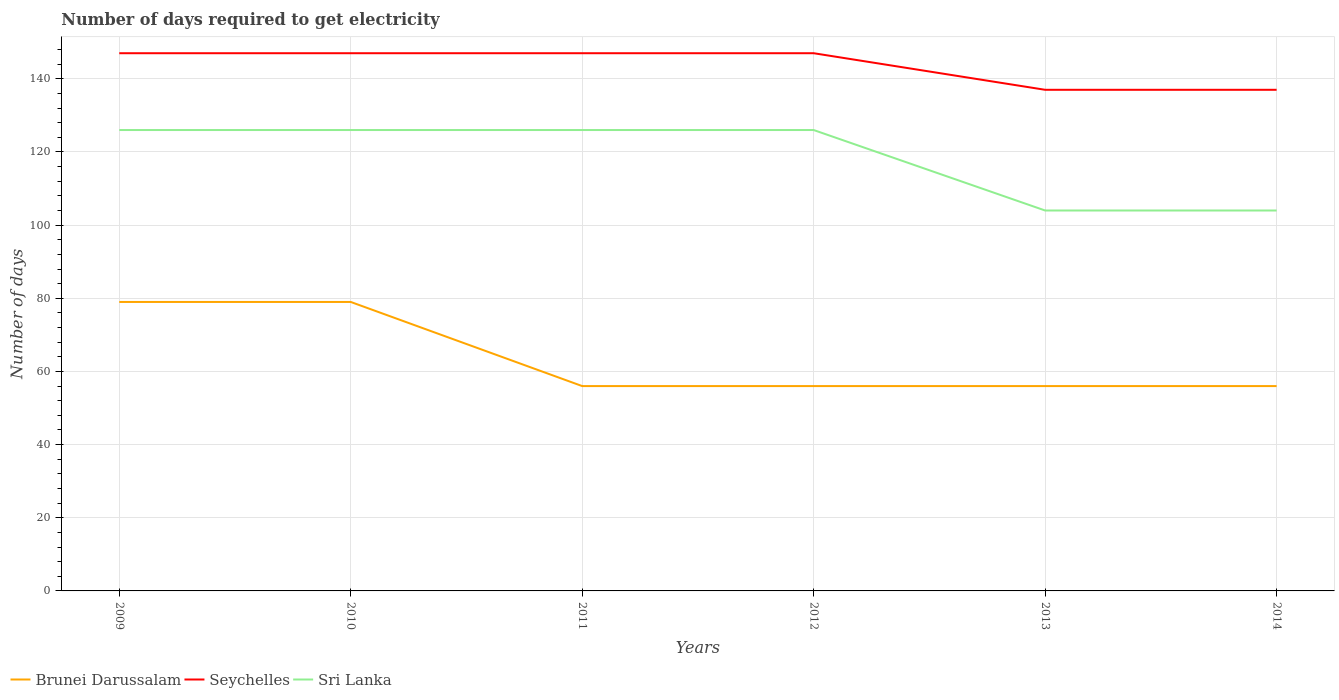Does the line corresponding to Sri Lanka intersect with the line corresponding to Seychelles?
Provide a succinct answer. No. Is the number of lines equal to the number of legend labels?
Your answer should be very brief. Yes. Across all years, what is the maximum number of days required to get electricity in in Brunei Darussalam?
Your answer should be very brief. 56. What is the total number of days required to get electricity in in Brunei Darussalam in the graph?
Your response must be concise. 23. What is the difference between the highest and the second highest number of days required to get electricity in in Brunei Darussalam?
Your answer should be very brief. 23. Is the number of days required to get electricity in in Seychelles strictly greater than the number of days required to get electricity in in Brunei Darussalam over the years?
Provide a succinct answer. No. How many lines are there?
Your answer should be very brief. 3. How many years are there in the graph?
Ensure brevity in your answer.  6. What is the difference between two consecutive major ticks on the Y-axis?
Make the answer very short. 20. What is the title of the graph?
Keep it short and to the point. Number of days required to get electricity. Does "Antigua and Barbuda" appear as one of the legend labels in the graph?
Keep it short and to the point. No. What is the label or title of the X-axis?
Offer a terse response. Years. What is the label or title of the Y-axis?
Your answer should be compact. Number of days. What is the Number of days in Brunei Darussalam in 2009?
Make the answer very short. 79. What is the Number of days of Seychelles in 2009?
Make the answer very short. 147. What is the Number of days of Sri Lanka in 2009?
Keep it short and to the point. 126. What is the Number of days in Brunei Darussalam in 2010?
Offer a terse response. 79. What is the Number of days in Seychelles in 2010?
Your answer should be compact. 147. What is the Number of days in Sri Lanka in 2010?
Offer a terse response. 126. What is the Number of days of Seychelles in 2011?
Offer a very short reply. 147. What is the Number of days in Sri Lanka in 2011?
Give a very brief answer. 126. What is the Number of days in Seychelles in 2012?
Make the answer very short. 147. What is the Number of days in Sri Lanka in 2012?
Your answer should be very brief. 126. What is the Number of days of Brunei Darussalam in 2013?
Offer a terse response. 56. What is the Number of days in Seychelles in 2013?
Keep it short and to the point. 137. What is the Number of days in Sri Lanka in 2013?
Keep it short and to the point. 104. What is the Number of days of Brunei Darussalam in 2014?
Keep it short and to the point. 56. What is the Number of days of Seychelles in 2014?
Your response must be concise. 137. What is the Number of days in Sri Lanka in 2014?
Provide a short and direct response. 104. Across all years, what is the maximum Number of days of Brunei Darussalam?
Provide a short and direct response. 79. Across all years, what is the maximum Number of days of Seychelles?
Make the answer very short. 147. Across all years, what is the maximum Number of days in Sri Lanka?
Your response must be concise. 126. Across all years, what is the minimum Number of days in Brunei Darussalam?
Provide a short and direct response. 56. Across all years, what is the minimum Number of days of Seychelles?
Offer a very short reply. 137. Across all years, what is the minimum Number of days in Sri Lanka?
Give a very brief answer. 104. What is the total Number of days in Brunei Darussalam in the graph?
Provide a succinct answer. 382. What is the total Number of days in Seychelles in the graph?
Offer a terse response. 862. What is the total Number of days of Sri Lanka in the graph?
Provide a succinct answer. 712. What is the difference between the Number of days of Brunei Darussalam in 2009 and that in 2010?
Provide a succinct answer. 0. What is the difference between the Number of days of Seychelles in 2009 and that in 2010?
Ensure brevity in your answer.  0. What is the difference between the Number of days in Brunei Darussalam in 2009 and that in 2011?
Your response must be concise. 23. What is the difference between the Number of days of Brunei Darussalam in 2009 and that in 2012?
Offer a terse response. 23. What is the difference between the Number of days of Seychelles in 2009 and that in 2012?
Make the answer very short. 0. What is the difference between the Number of days of Sri Lanka in 2009 and that in 2013?
Give a very brief answer. 22. What is the difference between the Number of days of Sri Lanka in 2009 and that in 2014?
Your response must be concise. 22. What is the difference between the Number of days of Seychelles in 2010 and that in 2011?
Make the answer very short. 0. What is the difference between the Number of days in Sri Lanka in 2010 and that in 2011?
Provide a short and direct response. 0. What is the difference between the Number of days in Brunei Darussalam in 2010 and that in 2014?
Offer a very short reply. 23. What is the difference between the Number of days in Seychelles in 2010 and that in 2014?
Offer a very short reply. 10. What is the difference between the Number of days in Sri Lanka in 2010 and that in 2014?
Make the answer very short. 22. What is the difference between the Number of days of Sri Lanka in 2011 and that in 2012?
Offer a terse response. 0. What is the difference between the Number of days in Brunei Darussalam in 2011 and that in 2013?
Offer a very short reply. 0. What is the difference between the Number of days of Brunei Darussalam in 2011 and that in 2014?
Give a very brief answer. 0. What is the difference between the Number of days in Seychelles in 2011 and that in 2014?
Provide a short and direct response. 10. What is the difference between the Number of days of Sri Lanka in 2012 and that in 2013?
Provide a succinct answer. 22. What is the difference between the Number of days of Brunei Darussalam in 2012 and that in 2014?
Your answer should be very brief. 0. What is the difference between the Number of days in Seychelles in 2012 and that in 2014?
Your answer should be compact. 10. What is the difference between the Number of days in Seychelles in 2013 and that in 2014?
Offer a terse response. 0. What is the difference between the Number of days of Sri Lanka in 2013 and that in 2014?
Provide a succinct answer. 0. What is the difference between the Number of days of Brunei Darussalam in 2009 and the Number of days of Seychelles in 2010?
Keep it short and to the point. -68. What is the difference between the Number of days of Brunei Darussalam in 2009 and the Number of days of Sri Lanka in 2010?
Give a very brief answer. -47. What is the difference between the Number of days in Brunei Darussalam in 2009 and the Number of days in Seychelles in 2011?
Offer a terse response. -68. What is the difference between the Number of days in Brunei Darussalam in 2009 and the Number of days in Sri Lanka in 2011?
Ensure brevity in your answer.  -47. What is the difference between the Number of days of Seychelles in 2009 and the Number of days of Sri Lanka in 2011?
Offer a very short reply. 21. What is the difference between the Number of days in Brunei Darussalam in 2009 and the Number of days in Seychelles in 2012?
Your answer should be compact. -68. What is the difference between the Number of days of Brunei Darussalam in 2009 and the Number of days of Sri Lanka in 2012?
Offer a very short reply. -47. What is the difference between the Number of days of Brunei Darussalam in 2009 and the Number of days of Seychelles in 2013?
Your answer should be compact. -58. What is the difference between the Number of days of Brunei Darussalam in 2009 and the Number of days of Sri Lanka in 2013?
Your answer should be very brief. -25. What is the difference between the Number of days in Brunei Darussalam in 2009 and the Number of days in Seychelles in 2014?
Make the answer very short. -58. What is the difference between the Number of days in Brunei Darussalam in 2010 and the Number of days in Seychelles in 2011?
Give a very brief answer. -68. What is the difference between the Number of days in Brunei Darussalam in 2010 and the Number of days in Sri Lanka in 2011?
Make the answer very short. -47. What is the difference between the Number of days in Seychelles in 2010 and the Number of days in Sri Lanka in 2011?
Keep it short and to the point. 21. What is the difference between the Number of days of Brunei Darussalam in 2010 and the Number of days of Seychelles in 2012?
Give a very brief answer. -68. What is the difference between the Number of days of Brunei Darussalam in 2010 and the Number of days of Sri Lanka in 2012?
Make the answer very short. -47. What is the difference between the Number of days in Brunei Darussalam in 2010 and the Number of days in Seychelles in 2013?
Provide a short and direct response. -58. What is the difference between the Number of days in Brunei Darussalam in 2010 and the Number of days in Sri Lanka in 2013?
Provide a short and direct response. -25. What is the difference between the Number of days in Seychelles in 2010 and the Number of days in Sri Lanka in 2013?
Ensure brevity in your answer.  43. What is the difference between the Number of days in Brunei Darussalam in 2010 and the Number of days in Seychelles in 2014?
Your answer should be very brief. -58. What is the difference between the Number of days of Brunei Darussalam in 2010 and the Number of days of Sri Lanka in 2014?
Make the answer very short. -25. What is the difference between the Number of days in Seychelles in 2010 and the Number of days in Sri Lanka in 2014?
Your answer should be very brief. 43. What is the difference between the Number of days in Brunei Darussalam in 2011 and the Number of days in Seychelles in 2012?
Your answer should be very brief. -91. What is the difference between the Number of days in Brunei Darussalam in 2011 and the Number of days in Sri Lanka in 2012?
Make the answer very short. -70. What is the difference between the Number of days in Seychelles in 2011 and the Number of days in Sri Lanka in 2012?
Your answer should be very brief. 21. What is the difference between the Number of days of Brunei Darussalam in 2011 and the Number of days of Seychelles in 2013?
Make the answer very short. -81. What is the difference between the Number of days of Brunei Darussalam in 2011 and the Number of days of Sri Lanka in 2013?
Keep it short and to the point. -48. What is the difference between the Number of days in Brunei Darussalam in 2011 and the Number of days in Seychelles in 2014?
Keep it short and to the point. -81. What is the difference between the Number of days in Brunei Darussalam in 2011 and the Number of days in Sri Lanka in 2014?
Provide a short and direct response. -48. What is the difference between the Number of days in Brunei Darussalam in 2012 and the Number of days in Seychelles in 2013?
Keep it short and to the point. -81. What is the difference between the Number of days of Brunei Darussalam in 2012 and the Number of days of Sri Lanka in 2013?
Ensure brevity in your answer.  -48. What is the difference between the Number of days in Brunei Darussalam in 2012 and the Number of days in Seychelles in 2014?
Ensure brevity in your answer.  -81. What is the difference between the Number of days in Brunei Darussalam in 2012 and the Number of days in Sri Lanka in 2014?
Keep it short and to the point. -48. What is the difference between the Number of days of Seychelles in 2012 and the Number of days of Sri Lanka in 2014?
Make the answer very short. 43. What is the difference between the Number of days in Brunei Darussalam in 2013 and the Number of days in Seychelles in 2014?
Make the answer very short. -81. What is the difference between the Number of days in Brunei Darussalam in 2013 and the Number of days in Sri Lanka in 2014?
Provide a succinct answer. -48. What is the difference between the Number of days in Seychelles in 2013 and the Number of days in Sri Lanka in 2014?
Offer a terse response. 33. What is the average Number of days in Brunei Darussalam per year?
Keep it short and to the point. 63.67. What is the average Number of days in Seychelles per year?
Provide a succinct answer. 143.67. What is the average Number of days of Sri Lanka per year?
Your response must be concise. 118.67. In the year 2009, what is the difference between the Number of days of Brunei Darussalam and Number of days of Seychelles?
Provide a short and direct response. -68. In the year 2009, what is the difference between the Number of days in Brunei Darussalam and Number of days in Sri Lanka?
Provide a succinct answer. -47. In the year 2010, what is the difference between the Number of days in Brunei Darussalam and Number of days in Seychelles?
Offer a terse response. -68. In the year 2010, what is the difference between the Number of days in Brunei Darussalam and Number of days in Sri Lanka?
Keep it short and to the point. -47. In the year 2010, what is the difference between the Number of days of Seychelles and Number of days of Sri Lanka?
Your answer should be very brief. 21. In the year 2011, what is the difference between the Number of days in Brunei Darussalam and Number of days in Seychelles?
Your answer should be compact. -91. In the year 2011, what is the difference between the Number of days in Brunei Darussalam and Number of days in Sri Lanka?
Make the answer very short. -70. In the year 2011, what is the difference between the Number of days in Seychelles and Number of days in Sri Lanka?
Offer a very short reply. 21. In the year 2012, what is the difference between the Number of days of Brunei Darussalam and Number of days of Seychelles?
Your answer should be very brief. -91. In the year 2012, what is the difference between the Number of days of Brunei Darussalam and Number of days of Sri Lanka?
Keep it short and to the point. -70. In the year 2012, what is the difference between the Number of days of Seychelles and Number of days of Sri Lanka?
Provide a short and direct response. 21. In the year 2013, what is the difference between the Number of days of Brunei Darussalam and Number of days of Seychelles?
Ensure brevity in your answer.  -81. In the year 2013, what is the difference between the Number of days in Brunei Darussalam and Number of days in Sri Lanka?
Keep it short and to the point. -48. In the year 2013, what is the difference between the Number of days in Seychelles and Number of days in Sri Lanka?
Offer a very short reply. 33. In the year 2014, what is the difference between the Number of days of Brunei Darussalam and Number of days of Seychelles?
Make the answer very short. -81. In the year 2014, what is the difference between the Number of days of Brunei Darussalam and Number of days of Sri Lanka?
Provide a short and direct response. -48. In the year 2014, what is the difference between the Number of days of Seychelles and Number of days of Sri Lanka?
Keep it short and to the point. 33. What is the ratio of the Number of days of Seychelles in 2009 to that in 2010?
Keep it short and to the point. 1. What is the ratio of the Number of days of Sri Lanka in 2009 to that in 2010?
Your answer should be compact. 1. What is the ratio of the Number of days in Brunei Darussalam in 2009 to that in 2011?
Ensure brevity in your answer.  1.41. What is the ratio of the Number of days of Sri Lanka in 2009 to that in 2011?
Your response must be concise. 1. What is the ratio of the Number of days in Brunei Darussalam in 2009 to that in 2012?
Provide a succinct answer. 1.41. What is the ratio of the Number of days in Brunei Darussalam in 2009 to that in 2013?
Provide a short and direct response. 1.41. What is the ratio of the Number of days of Seychelles in 2009 to that in 2013?
Give a very brief answer. 1.07. What is the ratio of the Number of days in Sri Lanka in 2009 to that in 2013?
Your answer should be compact. 1.21. What is the ratio of the Number of days of Brunei Darussalam in 2009 to that in 2014?
Offer a terse response. 1.41. What is the ratio of the Number of days of Seychelles in 2009 to that in 2014?
Make the answer very short. 1.07. What is the ratio of the Number of days in Sri Lanka in 2009 to that in 2014?
Offer a terse response. 1.21. What is the ratio of the Number of days of Brunei Darussalam in 2010 to that in 2011?
Your answer should be very brief. 1.41. What is the ratio of the Number of days of Seychelles in 2010 to that in 2011?
Your answer should be very brief. 1. What is the ratio of the Number of days in Sri Lanka in 2010 to that in 2011?
Provide a short and direct response. 1. What is the ratio of the Number of days of Brunei Darussalam in 2010 to that in 2012?
Offer a terse response. 1.41. What is the ratio of the Number of days of Seychelles in 2010 to that in 2012?
Offer a terse response. 1. What is the ratio of the Number of days in Sri Lanka in 2010 to that in 2012?
Your response must be concise. 1. What is the ratio of the Number of days of Brunei Darussalam in 2010 to that in 2013?
Provide a short and direct response. 1.41. What is the ratio of the Number of days of Seychelles in 2010 to that in 2013?
Provide a short and direct response. 1.07. What is the ratio of the Number of days in Sri Lanka in 2010 to that in 2013?
Your answer should be compact. 1.21. What is the ratio of the Number of days in Brunei Darussalam in 2010 to that in 2014?
Your response must be concise. 1.41. What is the ratio of the Number of days of Seychelles in 2010 to that in 2014?
Ensure brevity in your answer.  1.07. What is the ratio of the Number of days in Sri Lanka in 2010 to that in 2014?
Provide a short and direct response. 1.21. What is the ratio of the Number of days of Seychelles in 2011 to that in 2012?
Provide a succinct answer. 1. What is the ratio of the Number of days of Sri Lanka in 2011 to that in 2012?
Your answer should be very brief. 1. What is the ratio of the Number of days in Brunei Darussalam in 2011 to that in 2013?
Offer a very short reply. 1. What is the ratio of the Number of days in Seychelles in 2011 to that in 2013?
Make the answer very short. 1.07. What is the ratio of the Number of days in Sri Lanka in 2011 to that in 2013?
Make the answer very short. 1.21. What is the ratio of the Number of days of Brunei Darussalam in 2011 to that in 2014?
Keep it short and to the point. 1. What is the ratio of the Number of days in Seychelles in 2011 to that in 2014?
Your answer should be very brief. 1.07. What is the ratio of the Number of days in Sri Lanka in 2011 to that in 2014?
Offer a terse response. 1.21. What is the ratio of the Number of days of Seychelles in 2012 to that in 2013?
Your answer should be compact. 1.07. What is the ratio of the Number of days of Sri Lanka in 2012 to that in 2013?
Offer a very short reply. 1.21. What is the ratio of the Number of days of Brunei Darussalam in 2012 to that in 2014?
Your answer should be compact. 1. What is the ratio of the Number of days of Seychelles in 2012 to that in 2014?
Provide a short and direct response. 1.07. What is the ratio of the Number of days of Sri Lanka in 2012 to that in 2014?
Your answer should be very brief. 1.21. What is the difference between the highest and the second highest Number of days in Brunei Darussalam?
Offer a terse response. 0. What is the difference between the highest and the second highest Number of days of Seychelles?
Offer a very short reply. 0. What is the difference between the highest and the lowest Number of days of Brunei Darussalam?
Ensure brevity in your answer.  23. 